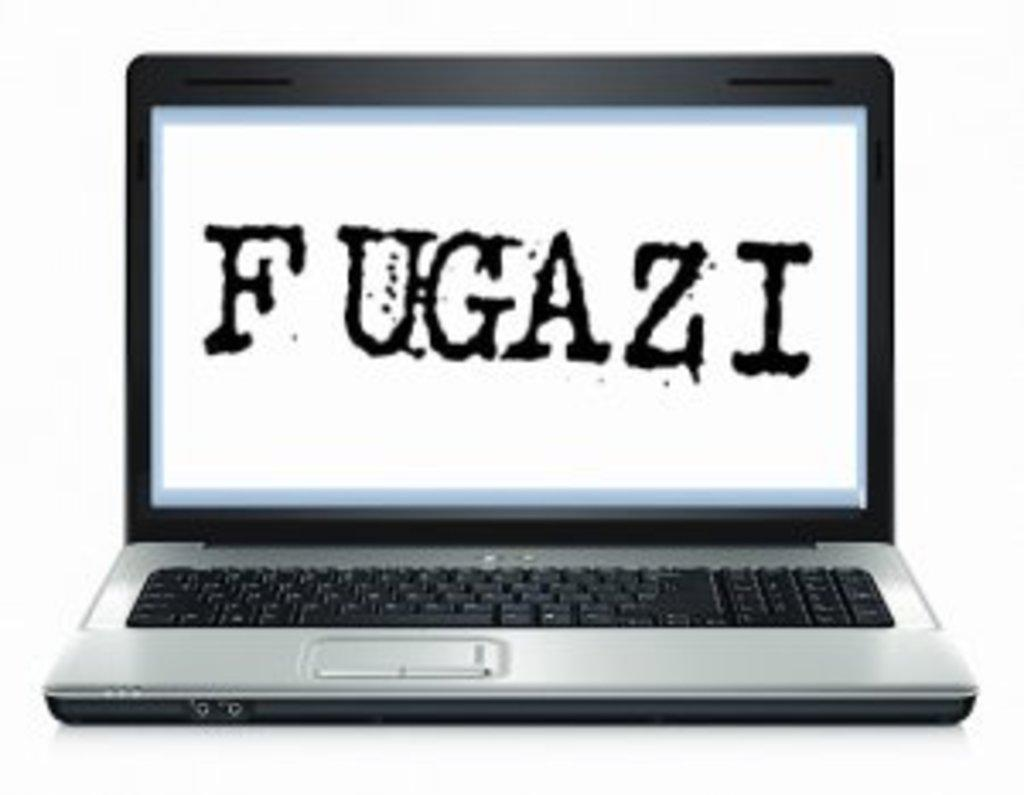<image>
Relay a brief, clear account of the picture shown. A computer with an image of the words FUGAZI on the screen. 